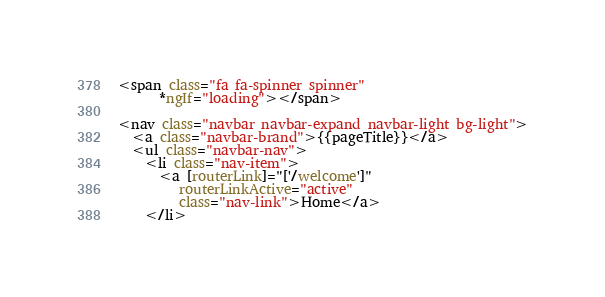Convert code to text. <code><loc_0><loc_0><loc_500><loc_500><_HTML_><span class="fa fa-spinner spinner"
      *ngIf="loading"></span>

<nav class="navbar navbar-expand navbar-light bg-light">
  <a class="navbar-brand">{{pageTitle}}</a>
  <ul class="navbar-nav">
    <li class="nav-item">
      <a [routerLink]="['/welcome']"
         routerLinkActive="active"
         class="nav-link">Home</a>
    </li></code> 